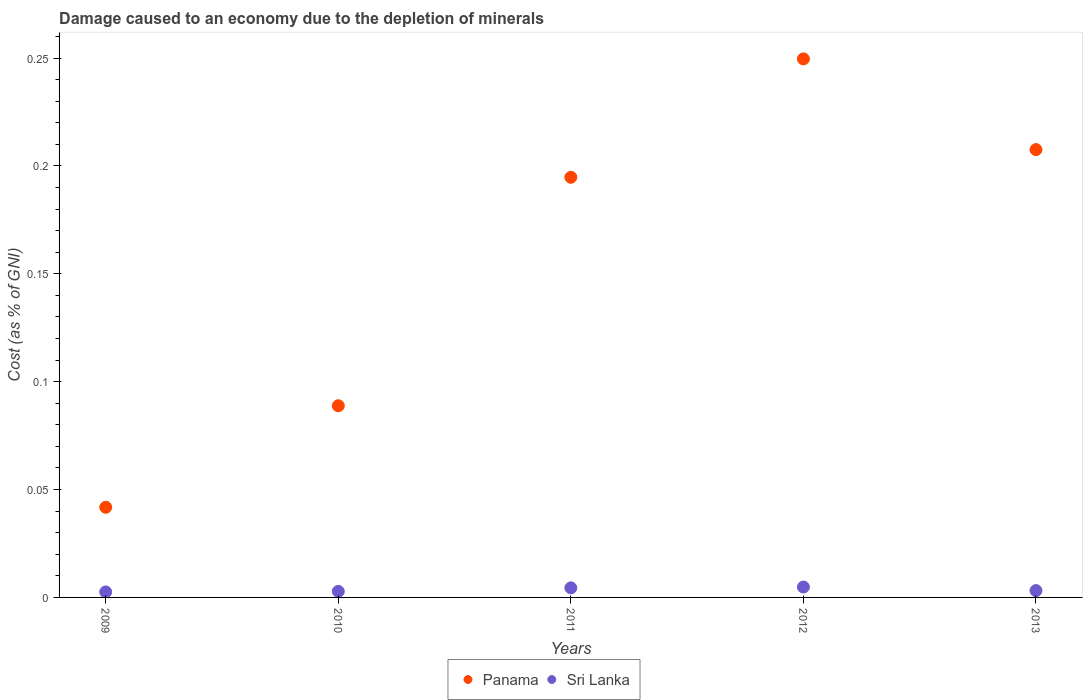What is the cost of damage caused due to the depletion of minerals in Panama in 2012?
Provide a short and direct response. 0.25. Across all years, what is the maximum cost of damage caused due to the depletion of minerals in Sri Lanka?
Keep it short and to the point. 0. Across all years, what is the minimum cost of damage caused due to the depletion of minerals in Panama?
Offer a terse response. 0.04. In which year was the cost of damage caused due to the depletion of minerals in Panama maximum?
Your answer should be compact. 2012. What is the total cost of damage caused due to the depletion of minerals in Panama in the graph?
Ensure brevity in your answer.  0.78. What is the difference between the cost of damage caused due to the depletion of minerals in Panama in 2009 and that in 2013?
Offer a terse response. -0.17. What is the difference between the cost of damage caused due to the depletion of minerals in Sri Lanka in 2013 and the cost of damage caused due to the depletion of minerals in Panama in 2009?
Your answer should be compact. -0.04. What is the average cost of damage caused due to the depletion of minerals in Sri Lanka per year?
Offer a terse response. 0. In the year 2012, what is the difference between the cost of damage caused due to the depletion of minerals in Sri Lanka and cost of damage caused due to the depletion of minerals in Panama?
Ensure brevity in your answer.  -0.24. What is the ratio of the cost of damage caused due to the depletion of minerals in Sri Lanka in 2009 to that in 2013?
Keep it short and to the point. 0.8. Is the cost of damage caused due to the depletion of minerals in Panama in 2011 less than that in 2012?
Offer a very short reply. Yes. What is the difference between the highest and the second highest cost of damage caused due to the depletion of minerals in Sri Lanka?
Offer a terse response. 0. What is the difference between the highest and the lowest cost of damage caused due to the depletion of minerals in Sri Lanka?
Keep it short and to the point. 0. Is the cost of damage caused due to the depletion of minerals in Sri Lanka strictly greater than the cost of damage caused due to the depletion of minerals in Panama over the years?
Ensure brevity in your answer.  No. Is the cost of damage caused due to the depletion of minerals in Sri Lanka strictly less than the cost of damage caused due to the depletion of minerals in Panama over the years?
Provide a short and direct response. Yes. How many dotlines are there?
Make the answer very short. 2. Does the graph contain any zero values?
Provide a succinct answer. No. Does the graph contain grids?
Make the answer very short. No. Where does the legend appear in the graph?
Ensure brevity in your answer.  Bottom center. How are the legend labels stacked?
Keep it short and to the point. Horizontal. What is the title of the graph?
Your answer should be very brief. Damage caused to an economy due to the depletion of minerals. What is the label or title of the Y-axis?
Give a very brief answer. Cost (as % of GNI). What is the Cost (as % of GNI) of Panama in 2009?
Keep it short and to the point. 0.04. What is the Cost (as % of GNI) of Sri Lanka in 2009?
Keep it short and to the point. 0. What is the Cost (as % of GNI) of Panama in 2010?
Your response must be concise. 0.09. What is the Cost (as % of GNI) of Sri Lanka in 2010?
Provide a succinct answer. 0. What is the Cost (as % of GNI) in Panama in 2011?
Provide a succinct answer. 0.19. What is the Cost (as % of GNI) in Sri Lanka in 2011?
Your response must be concise. 0. What is the Cost (as % of GNI) in Panama in 2012?
Your answer should be very brief. 0.25. What is the Cost (as % of GNI) of Sri Lanka in 2012?
Ensure brevity in your answer.  0. What is the Cost (as % of GNI) of Panama in 2013?
Offer a terse response. 0.21. What is the Cost (as % of GNI) of Sri Lanka in 2013?
Offer a terse response. 0. Across all years, what is the maximum Cost (as % of GNI) of Panama?
Ensure brevity in your answer.  0.25. Across all years, what is the maximum Cost (as % of GNI) in Sri Lanka?
Your answer should be very brief. 0. Across all years, what is the minimum Cost (as % of GNI) of Panama?
Your response must be concise. 0.04. Across all years, what is the minimum Cost (as % of GNI) in Sri Lanka?
Make the answer very short. 0. What is the total Cost (as % of GNI) in Panama in the graph?
Give a very brief answer. 0.78. What is the total Cost (as % of GNI) in Sri Lanka in the graph?
Ensure brevity in your answer.  0.02. What is the difference between the Cost (as % of GNI) in Panama in 2009 and that in 2010?
Give a very brief answer. -0.05. What is the difference between the Cost (as % of GNI) in Sri Lanka in 2009 and that in 2010?
Your answer should be compact. -0. What is the difference between the Cost (as % of GNI) of Panama in 2009 and that in 2011?
Your answer should be very brief. -0.15. What is the difference between the Cost (as % of GNI) in Sri Lanka in 2009 and that in 2011?
Provide a short and direct response. -0. What is the difference between the Cost (as % of GNI) in Panama in 2009 and that in 2012?
Offer a very short reply. -0.21. What is the difference between the Cost (as % of GNI) of Sri Lanka in 2009 and that in 2012?
Give a very brief answer. -0. What is the difference between the Cost (as % of GNI) of Panama in 2009 and that in 2013?
Your response must be concise. -0.17. What is the difference between the Cost (as % of GNI) of Sri Lanka in 2009 and that in 2013?
Your answer should be compact. -0. What is the difference between the Cost (as % of GNI) in Panama in 2010 and that in 2011?
Provide a short and direct response. -0.11. What is the difference between the Cost (as % of GNI) in Sri Lanka in 2010 and that in 2011?
Your answer should be compact. -0. What is the difference between the Cost (as % of GNI) of Panama in 2010 and that in 2012?
Offer a very short reply. -0.16. What is the difference between the Cost (as % of GNI) of Sri Lanka in 2010 and that in 2012?
Provide a succinct answer. -0. What is the difference between the Cost (as % of GNI) in Panama in 2010 and that in 2013?
Ensure brevity in your answer.  -0.12. What is the difference between the Cost (as % of GNI) of Sri Lanka in 2010 and that in 2013?
Offer a terse response. -0. What is the difference between the Cost (as % of GNI) in Panama in 2011 and that in 2012?
Your response must be concise. -0.05. What is the difference between the Cost (as % of GNI) in Sri Lanka in 2011 and that in 2012?
Provide a succinct answer. -0. What is the difference between the Cost (as % of GNI) of Panama in 2011 and that in 2013?
Provide a succinct answer. -0.01. What is the difference between the Cost (as % of GNI) in Sri Lanka in 2011 and that in 2013?
Your response must be concise. 0. What is the difference between the Cost (as % of GNI) in Panama in 2012 and that in 2013?
Give a very brief answer. 0.04. What is the difference between the Cost (as % of GNI) of Sri Lanka in 2012 and that in 2013?
Your response must be concise. 0. What is the difference between the Cost (as % of GNI) of Panama in 2009 and the Cost (as % of GNI) of Sri Lanka in 2010?
Your answer should be compact. 0.04. What is the difference between the Cost (as % of GNI) in Panama in 2009 and the Cost (as % of GNI) in Sri Lanka in 2011?
Your response must be concise. 0.04. What is the difference between the Cost (as % of GNI) in Panama in 2009 and the Cost (as % of GNI) in Sri Lanka in 2012?
Your response must be concise. 0.04. What is the difference between the Cost (as % of GNI) of Panama in 2009 and the Cost (as % of GNI) of Sri Lanka in 2013?
Provide a succinct answer. 0.04. What is the difference between the Cost (as % of GNI) in Panama in 2010 and the Cost (as % of GNI) in Sri Lanka in 2011?
Provide a succinct answer. 0.08. What is the difference between the Cost (as % of GNI) in Panama in 2010 and the Cost (as % of GNI) in Sri Lanka in 2012?
Provide a succinct answer. 0.08. What is the difference between the Cost (as % of GNI) in Panama in 2010 and the Cost (as % of GNI) in Sri Lanka in 2013?
Provide a succinct answer. 0.09. What is the difference between the Cost (as % of GNI) of Panama in 2011 and the Cost (as % of GNI) of Sri Lanka in 2012?
Your answer should be compact. 0.19. What is the difference between the Cost (as % of GNI) in Panama in 2011 and the Cost (as % of GNI) in Sri Lanka in 2013?
Offer a terse response. 0.19. What is the difference between the Cost (as % of GNI) in Panama in 2012 and the Cost (as % of GNI) in Sri Lanka in 2013?
Your answer should be compact. 0.25. What is the average Cost (as % of GNI) of Panama per year?
Provide a short and direct response. 0.16. What is the average Cost (as % of GNI) in Sri Lanka per year?
Provide a succinct answer. 0. In the year 2009, what is the difference between the Cost (as % of GNI) of Panama and Cost (as % of GNI) of Sri Lanka?
Your answer should be compact. 0.04. In the year 2010, what is the difference between the Cost (as % of GNI) in Panama and Cost (as % of GNI) in Sri Lanka?
Your response must be concise. 0.09. In the year 2011, what is the difference between the Cost (as % of GNI) in Panama and Cost (as % of GNI) in Sri Lanka?
Provide a succinct answer. 0.19. In the year 2012, what is the difference between the Cost (as % of GNI) in Panama and Cost (as % of GNI) in Sri Lanka?
Provide a succinct answer. 0.24. In the year 2013, what is the difference between the Cost (as % of GNI) of Panama and Cost (as % of GNI) of Sri Lanka?
Provide a short and direct response. 0.2. What is the ratio of the Cost (as % of GNI) in Panama in 2009 to that in 2010?
Give a very brief answer. 0.47. What is the ratio of the Cost (as % of GNI) of Sri Lanka in 2009 to that in 2010?
Make the answer very short. 0.91. What is the ratio of the Cost (as % of GNI) of Panama in 2009 to that in 2011?
Give a very brief answer. 0.21. What is the ratio of the Cost (as % of GNI) in Sri Lanka in 2009 to that in 2011?
Offer a very short reply. 0.57. What is the ratio of the Cost (as % of GNI) of Panama in 2009 to that in 2012?
Your answer should be very brief. 0.17. What is the ratio of the Cost (as % of GNI) of Sri Lanka in 2009 to that in 2012?
Give a very brief answer. 0.53. What is the ratio of the Cost (as % of GNI) in Panama in 2009 to that in 2013?
Your answer should be compact. 0.2. What is the ratio of the Cost (as % of GNI) of Sri Lanka in 2009 to that in 2013?
Offer a very short reply. 0.8. What is the ratio of the Cost (as % of GNI) of Panama in 2010 to that in 2011?
Offer a very short reply. 0.46. What is the ratio of the Cost (as % of GNI) of Sri Lanka in 2010 to that in 2011?
Provide a succinct answer. 0.63. What is the ratio of the Cost (as % of GNI) in Panama in 2010 to that in 2012?
Your answer should be compact. 0.36. What is the ratio of the Cost (as % of GNI) of Sri Lanka in 2010 to that in 2012?
Provide a short and direct response. 0.58. What is the ratio of the Cost (as % of GNI) in Panama in 2010 to that in 2013?
Offer a very short reply. 0.43. What is the ratio of the Cost (as % of GNI) in Sri Lanka in 2010 to that in 2013?
Give a very brief answer. 0.89. What is the ratio of the Cost (as % of GNI) in Panama in 2011 to that in 2012?
Ensure brevity in your answer.  0.78. What is the ratio of the Cost (as % of GNI) in Sri Lanka in 2011 to that in 2012?
Keep it short and to the point. 0.92. What is the ratio of the Cost (as % of GNI) of Panama in 2011 to that in 2013?
Ensure brevity in your answer.  0.94. What is the ratio of the Cost (as % of GNI) in Sri Lanka in 2011 to that in 2013?
Your answer should be compact. 1.4. What is the ratio of the Cost (as % of GNI) in Panama in 2012 to that in 2013?
Offer a terse response. 1.2. What is the ratio of the Cost (as % of GNI) in Sri Lanka in 2012 to that in 2013?
Make the answer very short. 1.52. What is the difference between the highest and the second highest Cost (as % of GNI) in Panama?
Give a very brief answer. 0.04. What is the difference between the highest and the second highest Cost (as % of GNI) in Sri Lanka?
Offer a terse response. 0. What is the difference between the highest and the lowest Cost (as % of GNI) of Panama?
Make the answer very short. 0.21. What is the difference between the highest and the lowest Cost (as % of GNI) of Sri Lanka?
Give a very brief answer. 0. 